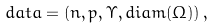<formula> <loc_0><loc_0><loc_500><loc_500>d a t a = \left ( n , p , \Upsilon , d i a m ( \Omega ) \right ) ,</formula> 